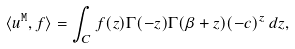Convert formula to latex. <formula><loc_0><loc_0><loc_500><loc_500>\langle { u } ^ { \tt M } , f \rangle = \int _ { C } f ( z ) \Gamma ( - z ) \Gamma ( \beta + z ) ( - c ) ^ { z } \, d z ,</formula> 